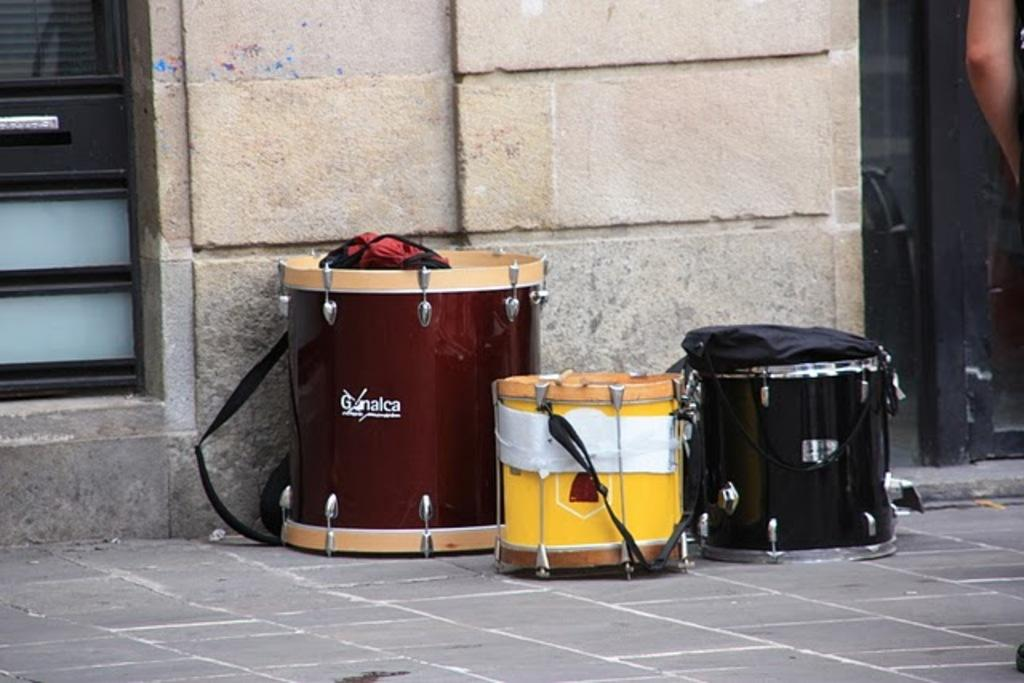What type of musical instrument is present in the image? There are musical drums in the image. What else can be seen in the image besides the drums? There are bags in the image. How many doors are visible in the image? There are doors on the left and right sides of the image. What is the appearance of the doors in the image? The doors appear to be truncated. What is the background of the image made of? There is a wall in the image. Can you see any children starting to play the drums in the image? There are no children present in the image, nor is there any indication that the drums are being played. Is there an airplane visible in the image? There is no airplane present in the image. 